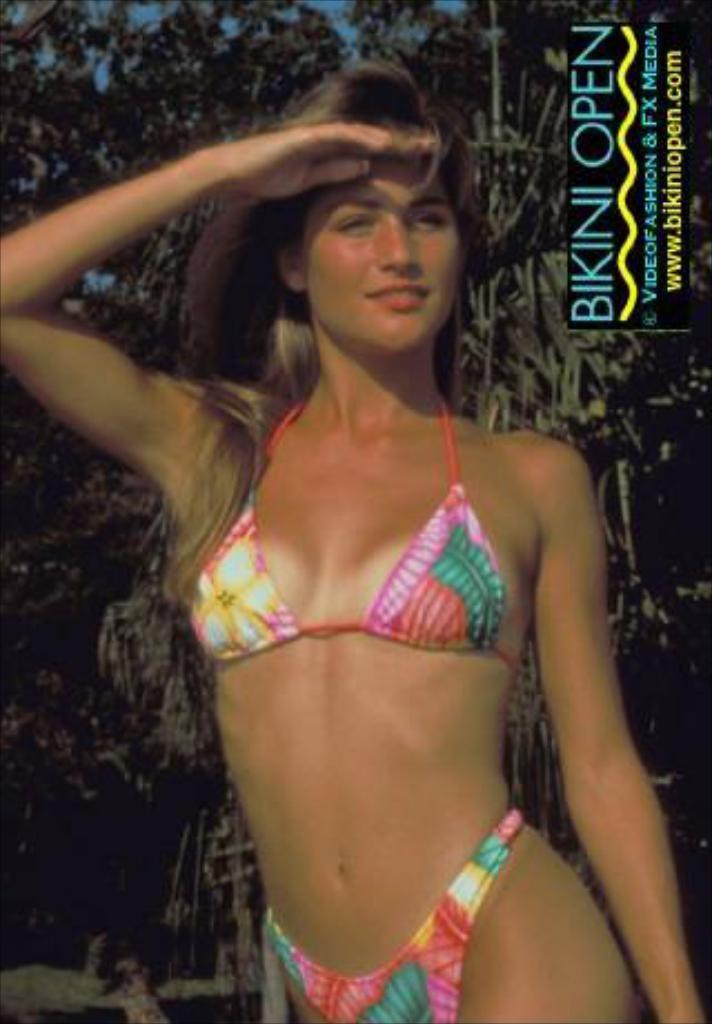Describe this image in one or two sentences. In this image I can see a woman standing and smiling by looking at the right side. In the background there are some trees. It seems to be a poster. In the top right there is some text. 